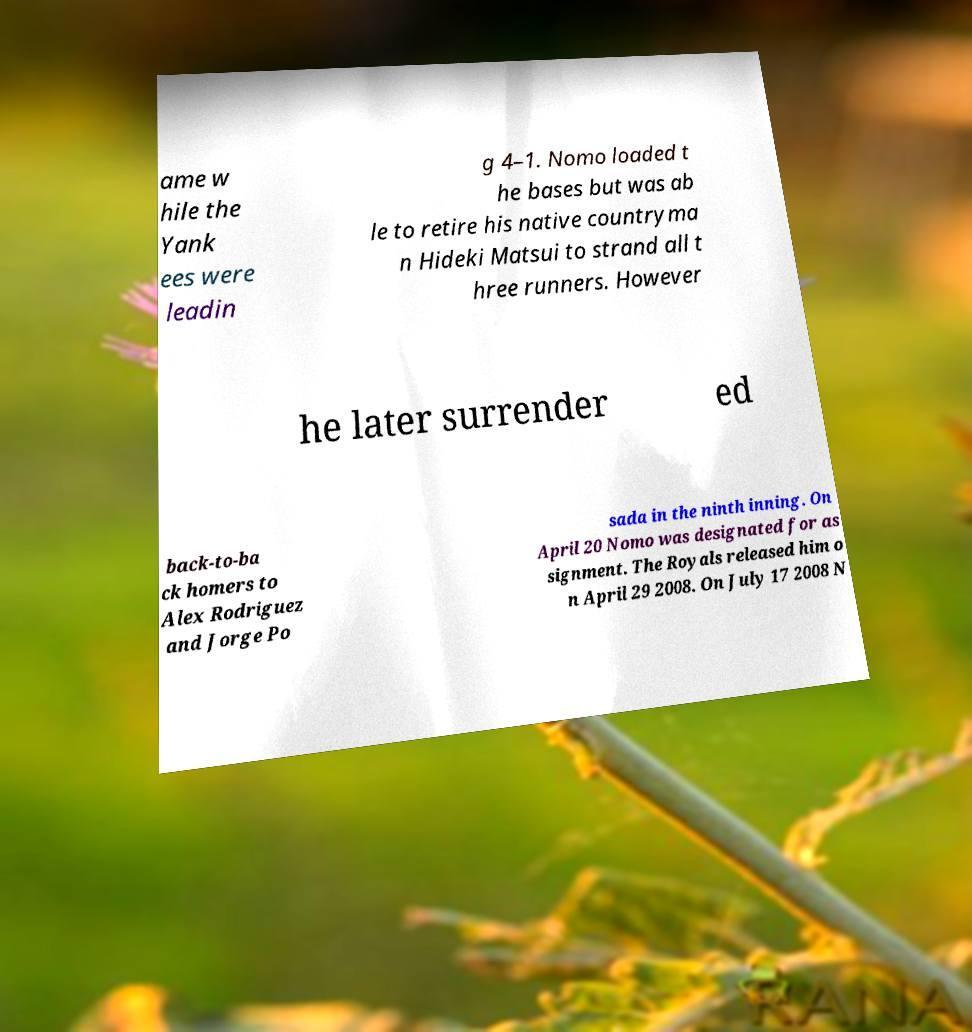Could you assist in decoding the text presented in this image and type it out clearly? ame w hile the Yank ees were leadin g 4–1. Nomo loaded t he bases but was ab le to retire his native countryma n Hideki Matsui to strand all t hree runners. However he later surrender ed back-to-ba ck homers to Alex Rodriguez and Jorge Po sada in the ninth inning. On April 20 Nomo was designated for as signment. The Royals released him o n April 29 2008. On July 17 2008 N 